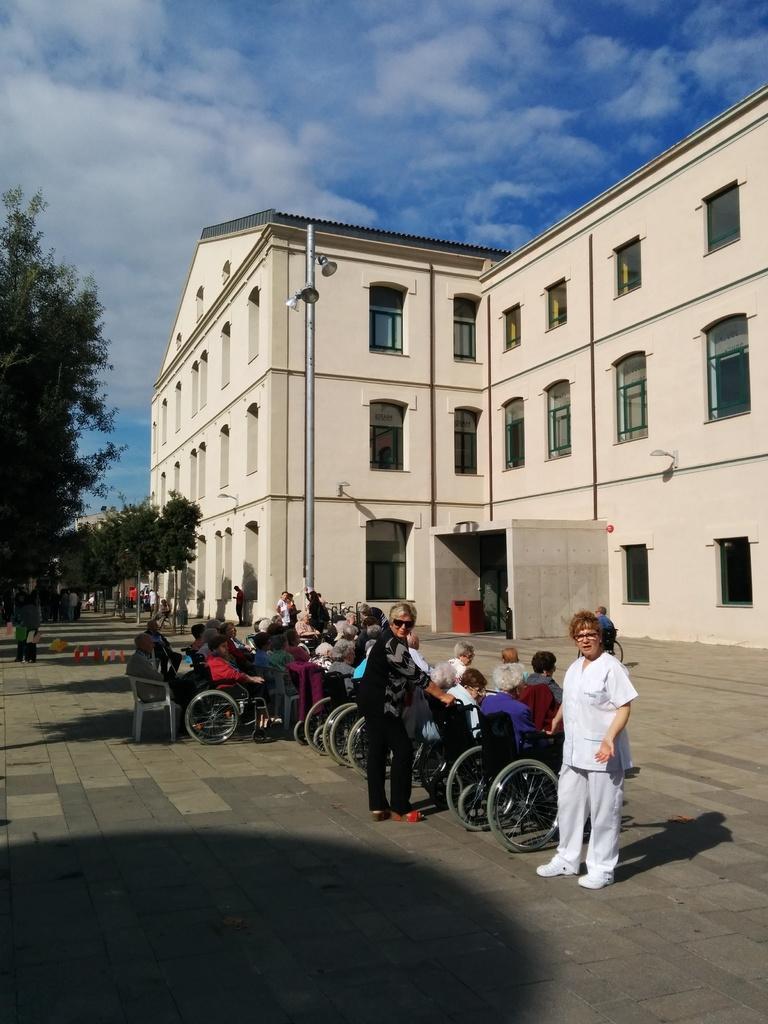Could you give a brief overview of what you see in this image? In this picture there is a building in the center of the image and there are trees on the left side of the image, there are people those who are sitting on wheelchairs in the center of the image. 